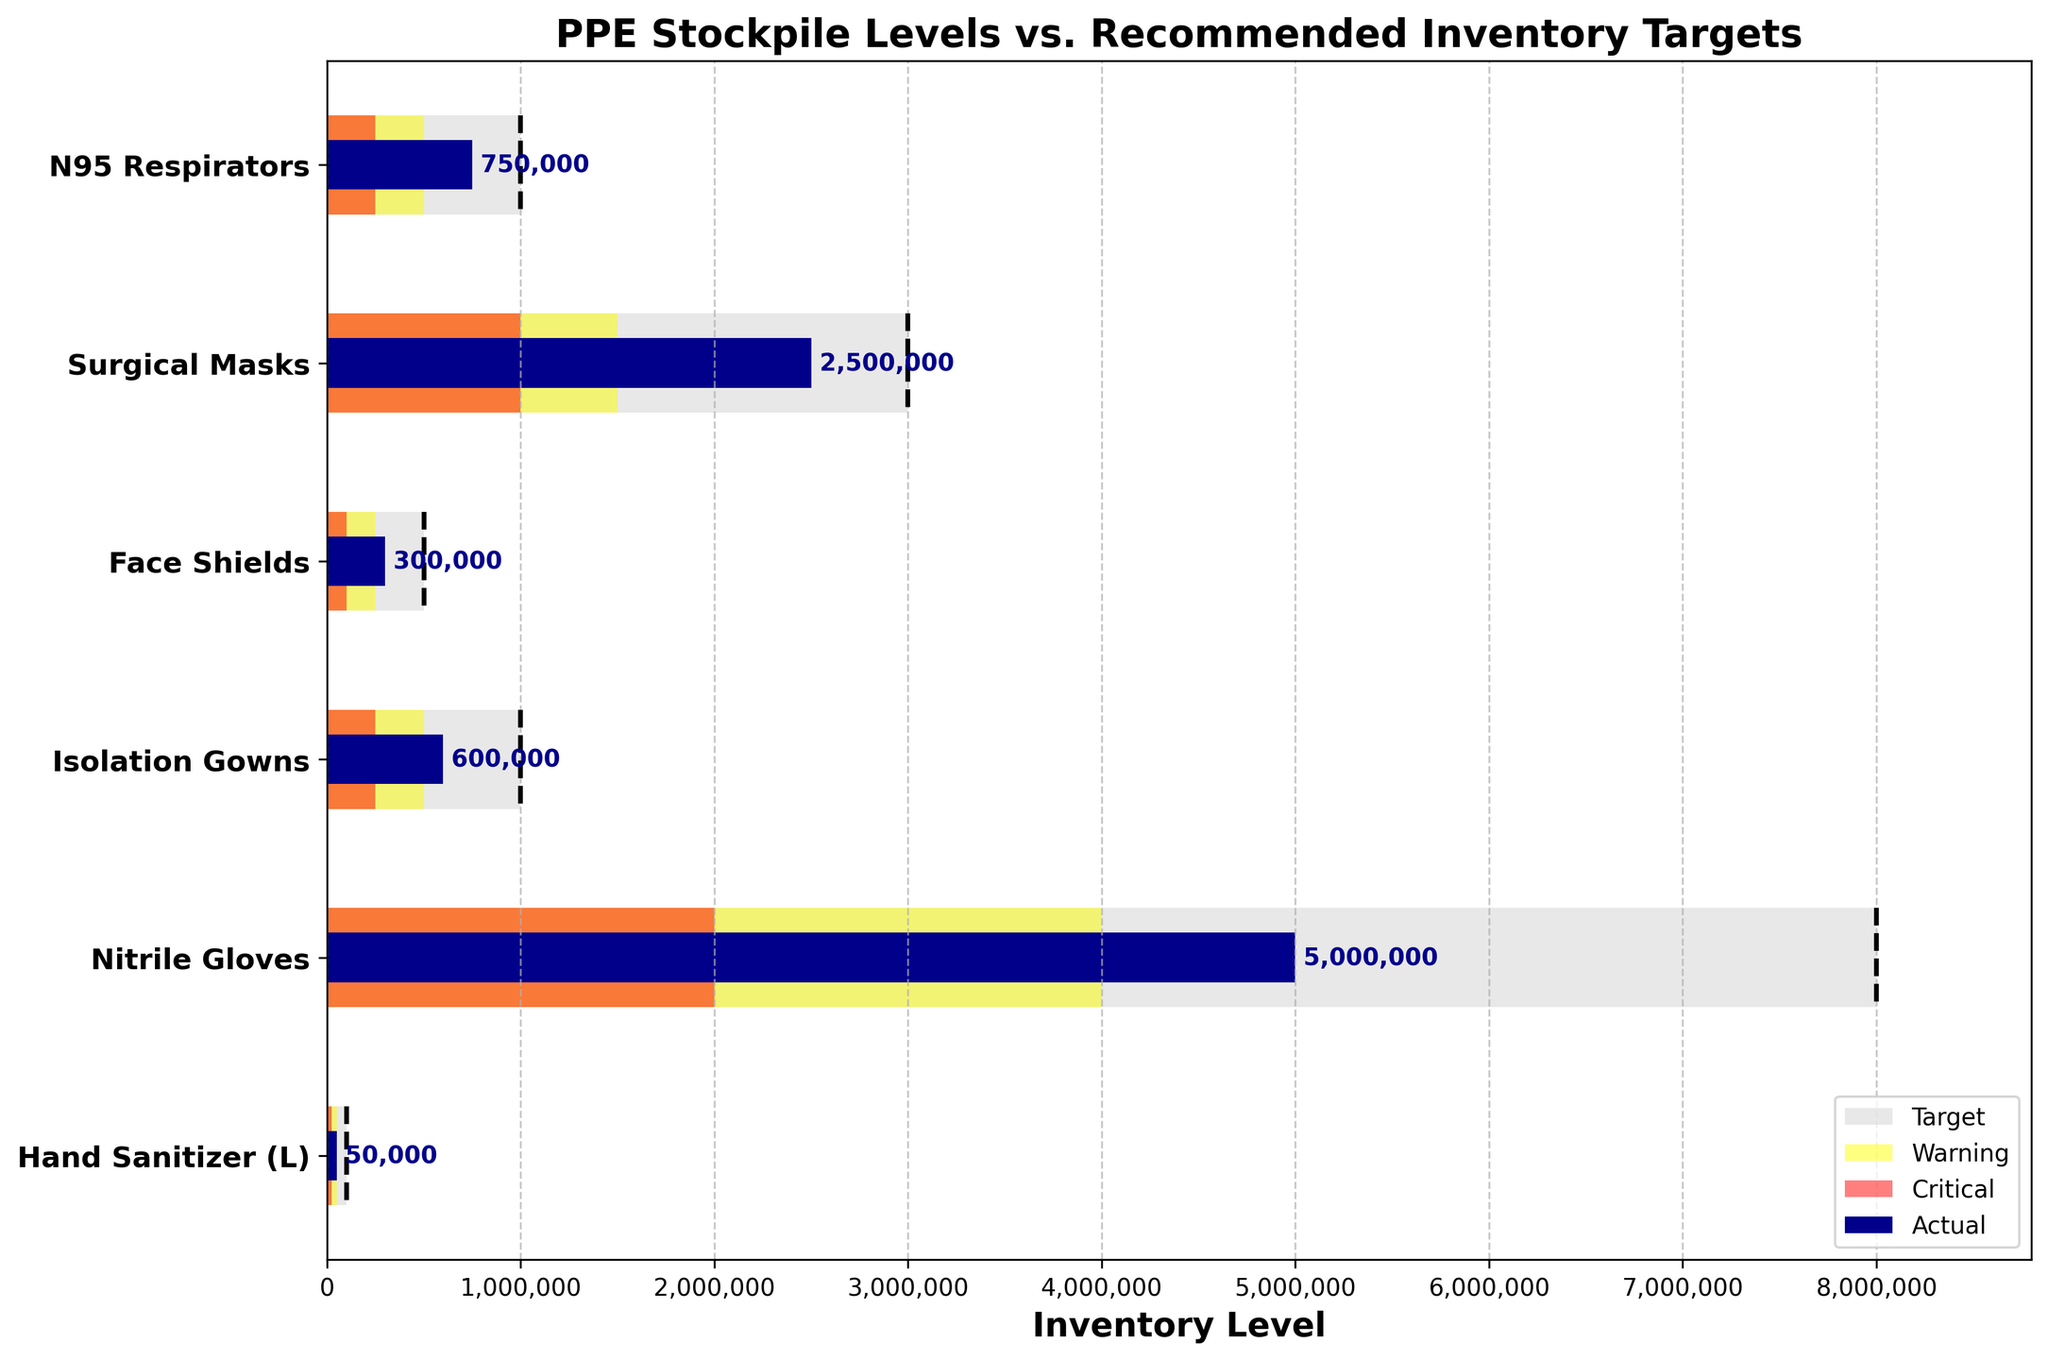What is the title of the plot? The title of the plot is located at the top and is clearly labeled. The information needed to answer this question is visible in the title itself.
Answer: PPE Stockpile Levels vs. Recommended Inventory Targets Which category has the highest actual inventory level? Look at the horizontal bars representing the "Actual" inventory levels for each category. Identify the bar that extends the furthest.
Answer: Nitrile Gloves How many categories have actual inventory levels below their target? Compare each "Actual" bar's length to its corresponding "Target" line. Count those that do not reach the "Target" line.
Answer: 5 How much less is the actual inventory of N95 Respirators compared to its target? Subtract the actual value of N95 Respirators from its target value.
Answer: 250,000 Which PPE category's actual inventory level meets or exceeds the warning threshold but not the target? Identify which categories have actual levels greater than or equal to their warning threshold but less than their target.
Answer: N95 Respirators and Isolation Gowns What is the ratio of actual to target inventory levels for Hand Sanitizer? Divide the actual inventory level by the target inventory level for Hand Sanitizer.
Answer: 0.5 Compare the actual inventory levels of Surgical Masks and Face Shields. Which one is higher? Compare the lengths of the "Actual" bars for Surgical Masks and Face Shields.
Answer: Surgical Masks Which category has the lowest critical threshold value? Look at the "Critical" threshold values for each category and find the smallest one.
Answer: Hand Sanitizer If the required target is doubled for N95 Respirators, does the actual inventory meet the new target? Double the "Target" value of N95 Respirators and compare it to the actual inventory level.
Answer: No What is the combined target inventory for Isolation Gowns and Nitrile Gloves? Sum the target values for Isolation Gowns and Nitrile Gloves.
Answer: 9,000,000 